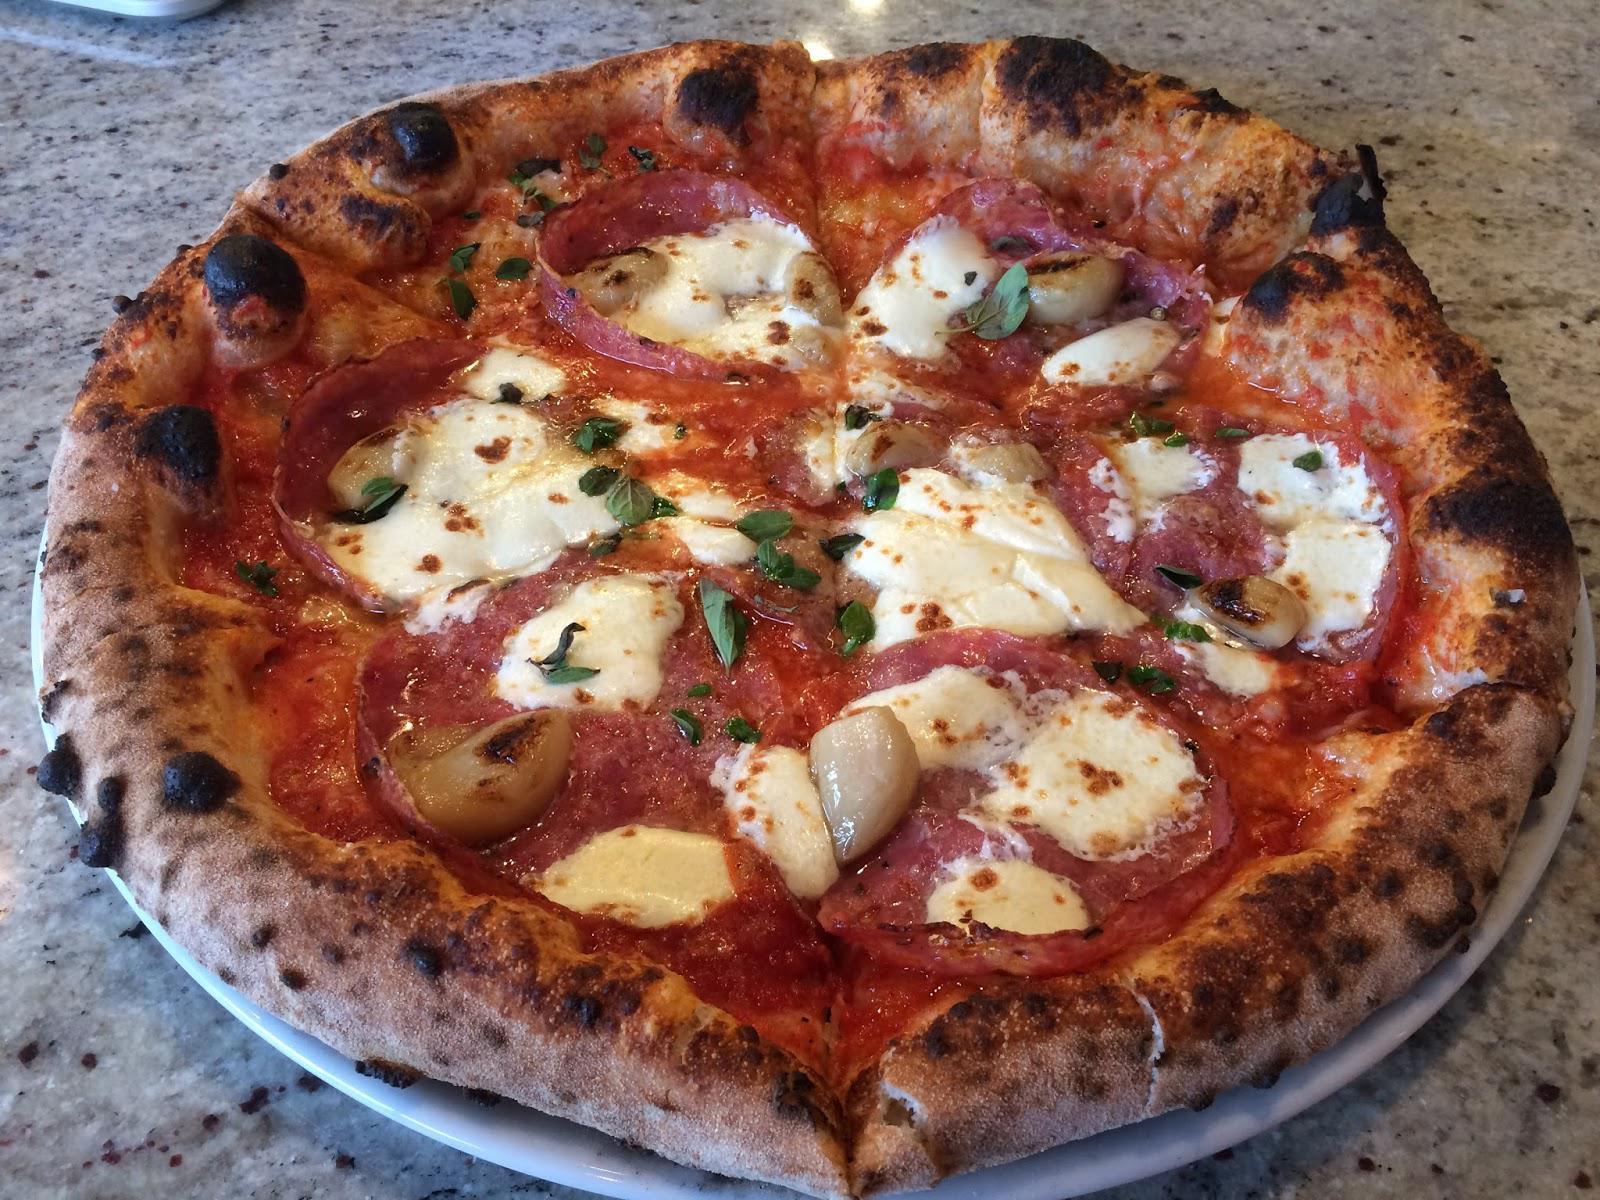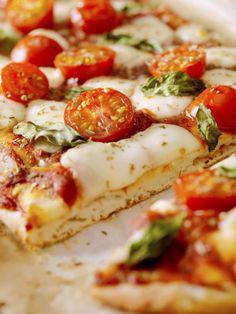The first image is the image on the left, the second image is the image on the right. For the images displayed, is the sentence "A pizza has sliced tomatoes." factually correct? Answer yes or no. Yes. The first image is the image on the left, the second image is the image on the right. Given the left and right images, does the statement "One image shows a baked, brown-crusted pizza with no slices removed, and the other image shows less than an entire pizza." hold true? Answer yes or no. Yes. 